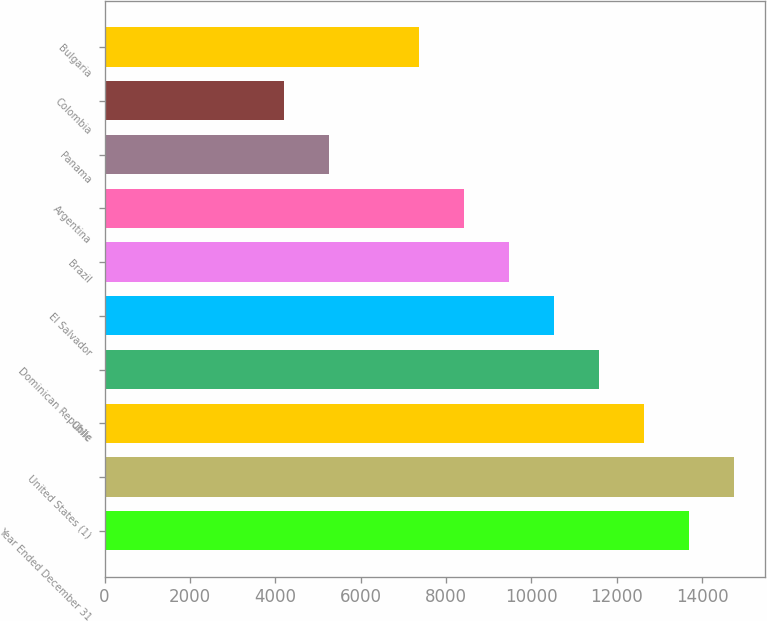Convert chart to OTSL. <chart><loc_0><loc_0><loc_500><loc_500><bar_chart><fcel>Year Ended December 31<fcel>United States (1)<fcel>Chile<fcel>Dominican Republic<fcel>El Salvador<fcel>Brazil<fcel>Argentina<fcel>Panama<fcel>Colombia<fcel>Bulgaria<nl><fcel>13687.5<fcel>14740<fcel>12635<fcel>11582.5<fcel>10530<fcel>9477.5<fcel>8425<fcel>5267.5<fcel>4215<fcel>7372.5<nl></chart> 